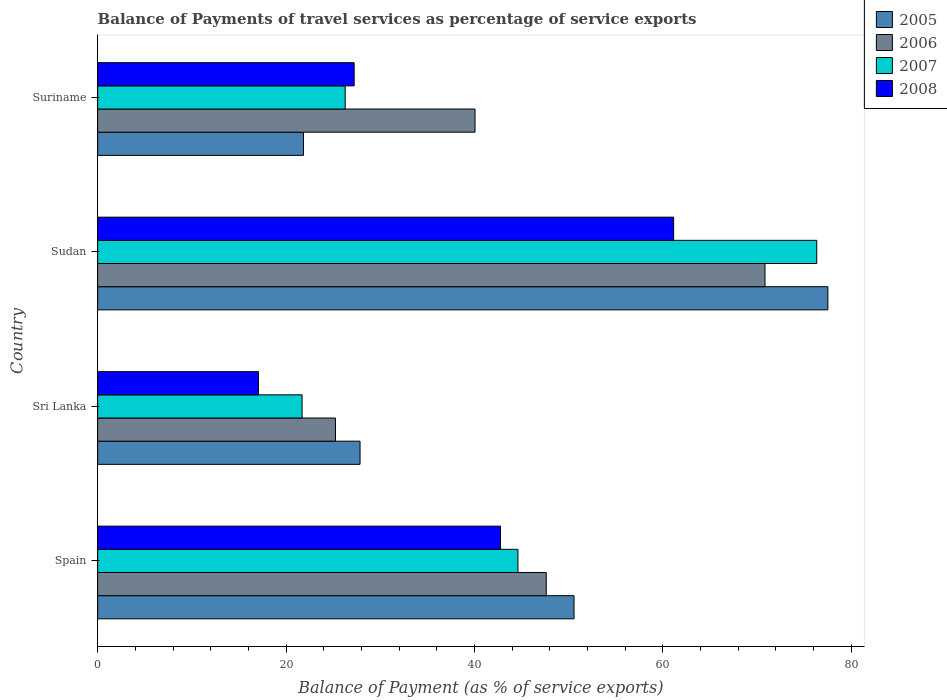How many different coloured bars are there?
Your answer should be very brief. 4. Are the number of bars per tick equal to the number of legend labels?
Provide a succinct answer. Yes. Are the number of bars on each tick of the Y-axis equal?
Your response must be concise. Yes. What is the label of the 2nd group of bars from the top?
Your response must be concise. Sudan. In how many cases, is the number of bars for a given country not equal to the number of legend labels?
Give a very brief answer. 0. What is the balance of payments of travel services in 2008 in Suriname?
Provide a short and direct response. 27.23. Across all countries, what is the maximum balance of payments of travel services in 2006?
Make the answer very short. 70.85. Across all countries, what is the minimum balance of payments of travel services in 2008?
Offer a terse response. 17.08. In which country was the balance of payments of travel services in 2005 maximum?
Provide a succinct answer. Sudan. In which country was the balance of payments of travel services in 2005 minimum?
Offer a terse response. Suriname. What is the total balance of payments of travel services in 2005 in the graph?
Offer a very short reply. 177.82. What is the difference between the balance of payments of travel services in 2005 in Spain and that in Suriname?
Your answer should be compact. 28.73. What is the difference between the balance of payments of travel services in 2007 in Sudan and the balance of payments of travel services in 2005 in Sri Lanka?
Provide a short and direct response. 48.49. What is the average balance of payments of travel services in 2005 per country?
Make the answer very short. 44.45. What is the difference between the balance of payments of travel services in 2008 and balance of payments of travel services in 2005 in Sri Lanka?
Ensure brevity in your answer.  -10.78. In how many countries, is the balance of payments of travel services in 2007 greater than 48 %?
Give a very brief answer. 1. What is the ratio of the balance of payments of travel services in 2008 in Sri Lanka to that in Sudan?
Offer a terse response. 0.28. Is the balance of payments of travel services in 2006 in Sudan less than that in Suriname?
Your answer should be very brief. No. Is the difference between the balance of payments of travel services in 2008 in Spain and Suriname greater than the difference between the balance of payments of travel services in 2005 in Spain and Suriname?
Offer a very short reply. No. What is the difference between the highest and the second highest balance of payments of travel services in 2007?
Your response must be concise. 31.73. What is the difference between the highest and the lowest balance of payments of travel services in 2006?
Your answer should be very brief. 45.6. In how many countries, is the balance of payments of travel services in 2008 greater than the average balance of payments of travel services in 2008 taken over all countries?
Give a very brief answer. 2. What does the 4th bar from the top in Spain represents?
Keep it short and to the point. 2005. What is the difference between two consecutive major ticks on the X-axis?
Make the answer very short. 20. Does the graph contain grids?
Make the answer very short. No. What is the title of the graph?
Keep it short and to the point. Balance of Payments of travel services as percentage of service exports. What is the label or title of the X-axis?
Give a very brief answer. Balance of Payment (as % of service exports). What is the Balance of Payment (as % of service exports) of 2005 in Spain?
Ensure brevity in your answer.  50.58. What is the Balance of Payment (as % of service exports) in 2006 in Spain?
Ensure brevity in your answer.  47.63. What is the Balance of Payment (as % of service exports) in 2007 in Spain?
Your answer should be compact. 44.62. What is the Balance of Payment (as % of service exports) in 2008 in Spain?
Offer a terse response. 42.78. What is the Balance of Payment (as % of service exports) in 2005 in Sri Lanka?
Make the answer very short. 27.86. What is the Balance of Payment (as % of service exports) in 2006 in Sri Lanka?
Your answer should be compact. 25.25. What is the Balance of Payment (as % of service exports) of 2007 in Sri Lanka?
Provide a short and direct response. 21.71. What is the Balance of Payment (as % of service exports) in 2008 in Sri Lanka?
Provide a succinct answer. 17.08. What is the Balance of Payment (as % of service exports) in 2005 in Sudan?
Provide a succinct answer. 77.53. What is the Balance of Payment (as % of service exports) in 2006 in Sudan?
Provide a short and direct response. 70.85. What is the Balance of Payment (as % of service exports) of 2007 in Sudan?
Provide a short and direct response. 76.35. What is the Balance of Payment (as % of service exports) in 2008 in Sudan?
Your response must be concise. 61.15. What is the Balance of Payment (as % of service exports) of 2005 in Suriname?
Keep it short and to the point. 21.85. What is the Balance of Payment (as % of service exports) in 2006 in Suriname?
Your response must be concise. 40.07. What is the Balance of Payment (as % of service exports) in 2007 in Suriname?
Your answer should be very brief. 26.28. What is the Balance of Payment (as % of service exports) in 2008 in Suriname?
Offer a very short reply. 27.23. Across all countries, what is the maximum Balance of Payment (as % of service exports) of 2005?
Offer a very short reply. 77.53. Across all countries, what is the maximum Balance of Payment (as % of service exports) in 2006?
Give a very brief answer. 70.85. Across all countries, what is the maximum Balance of Payment (as % of service exports) of 2007?
Offer a very short reply. 76.35. Across all countries, what is the maximum Balance of Payment (as % of service exports) of 2008?
Your answer should be very brief. 61.15. Across all countries, what is the minimum Balance of Payment (as % of service exports) in 2005?
Your answer should be compact. 21.85. Across all countries, what is the minimum Balance of Payment (as % of service exports) in 2006?
Provide a succinct answer. 25.25. Across all countries, what is the minimum Balance of Payment (as % of service exports) in 2007?
Provide a short and direct response. 21.71. Across all countries, what is the minimum Balance of Payment (as % of service exports) in 2008?
Your answer should be very brief. 17.08. What is the total Balance of Payment (as % of service exports) in 2005 in the graph?
Offer a terse response. 177.82. What is the total Balance of Payment (as % of service exports) of 2006 in the graph?
Offer a very short reply. 183.8. What is the total Balance of Payment (as % of service exports) of 2007 in the graph?
Offer a terse response. 168.96. What is the total Balance of Payment (as % of service exports) in 2008 in the graph?
Keep it short and to the point. 148.24. What is the difference between the Balance of Payment (as % of service exports) in 2005 in Spain and that in Sri Lanka?
Your answer should be compact. 22.72. What is the difference between the Balance of Payment (as % of service exports) in 2006 in Spain and that in Sri Lanka?
Give a very brief answer. 22.38. What is the difference between the Balance of Payment (as % of service exports) of 2007 in Spain and that in Sri Lanka?
Offer a terse response. 22.92. What is the difference between the Balance of Payment (as % of service exports) of 2008 in Spain and that in Sri Lanka?
Your response must be concise. 25.7. What is the difference between the Balance of Payment (as % of service exports) of 2005 in Spain and that in Sudan?
Your response must be concise. -26.95. What is the difference between the Balance of Payment (as % of service exports) in 2006 in Spain and that in Sudan?
Provide a succinct answer. -23.22. What is the difference between the Balance of Payment (as % of service exports) of 2007 in Spain and that in Sudan?
Your answer should be very brief. -31.73. What is the difference between the Balance of Payment (as % of service exports) in 2008 in Spain and that in Sudan?
Give a very brief answer. -18.38. What is the difference between the Balance of Payment (as % of service exports) in 2005 in Spain and that in Suriname?
Provide a succinct answer. 28.73. What is the difference between the Balance of Payment (as % of service exports) in 2006 in Spain and that in Suriname?
Provide a succinct answer. 7.56. What is the difference between the Balance of Payment (as % of service exports) in 2007 in Spain and that in Suriname?
Provide a short and direct response. 18.34. What is the difference between the Balance of Payment (as % of service exports) of 2008 in Spain and that in Suriname?
Give a very brief answer. 15.54. What is the difference between the Balance of Payment (as % of service exports) in 2005 in Sri Lanka and that in Sudan?
Make the answer very short. -49.67. What is the difference between the Balance of Payment (as % of service exports) in 2006 in Sri Lanka and that in Sudan?
Your answer should be very brief. -45.6. What is the difference between the Balance of Payment (as % of service exports) of 2007 in Sri Lanka and that in Sudan?
Keep it short and to the point. -54.64. What is the difference between the Balance of Payment (as % of service exports) of 2008 in Sri Lanka and that in Sudan?
Keep it short and to the point. -44.07. What is the difference between the Balance of Payment (as % of service exports) of 2005 in Sri Lanka and that in Suriname?
Give a very brief answer. 6.01. What is the difference between the Balance of Payment (as % of service exports) in 2006 in Sri Lanka and that in Suriname?
Keep it short and to the point. -14.82. What is the difference between the Balance of Payment (as % of service exports) of 2007 in Sri Lanka and that in Suriname?
Keep it short and to the point. -4.58. What is the difference between the Balance of Payment (as % of service exports) of 2008 in Sri Lanka and that in Suriname?
Your answer should be compact. -10.15. What is the difference between the Balance of Payment (as % of service exports) in 2005 in Sudan and that in Suriname?
Ensure brevity in your answer.  55.68. What is the difference between the Balance of Payment (as % of service exports) in 2006 in Sudan and that in Suriname?
Ensure brevity in your answer.  30.79. What is the difference between the Balance of Payment (as % of service exports) of 2007 in Sudan and that in Suriname?
Make the answer very short. 50.07. What is the difference between the Balance of Payment (as % of service exports) of 2008 in Sudan and that in Suriname?
Ensure brevity in your answer.  33.92. What is the difference between the Balance of Payment (as % of service exports) in 2005 in Spain and the Balance of Payment (as % of service exports) in 2006 in Sri Lanka?
Provide a succinct answer. 25.33. What is the difference between the Balance of Payment (as % of service exports) in 2005 in Spain and the Balance of Payment (as % of service exports) in 2007 in Sri Lanka?
Your response must be concise. 28.87. What is the difference between the Balance of Payment (as % of service exports) in 2005 in Spain and the Balance of Payment (as % of service exports) in 2008 in Sri Lanka?
Give a very brief answer. 33.5. What is the difference between the Balance of Payment (as % of service exports) of 2006 in Spain and the Balance of Payment (as % of service exports) of 2007 in Sri Lanka?
Provide a succinct answer. 25.92. What is the difference between the Balance of Payment (as % of service exports) of 2006 in Spain and the Balance of Payment (as % of service exports) of 2008 in Sri Lanka?
Provide a short and direct response. 30.55. What is the difference between the Balance of Payment (as % of service exports) in 2007 in Spain and the Balance of Payment (as % of service exports) in 2008 in Sri Lanka?
Provide a short and direct response. 27.54. What is the difference between the Balance of Payment (as % of service exports) of 2005 in Spain and the Balance of Payment (as % of service exports) of 2006 in Sudan?
Offer a terse response. -20.28. What is the difference between the Balance of Payment (as % of service exports) of 2005 in Spain and the Balance of Payment (as % of service exports) of 2007 in Sudan?
Offer a very short reply. -25.77. What is the difference between the Balance of Payment (as % of service exports) in 2005 in Spain and the Balance of Payment (as % of service exports) in 2008 in Sudan?
Provide a succinct answer. -10.57. What is the difference between the Balance of Payment (as % of service exports) of 2006 in Spain and the Balance of Payment (as % of service exports) of 2007 in Sudan?
Your answer should be very brief. -28.72. What is the difference between the Balance of Payment (as % of service exports) of 2006 in Spain and the Balance of Payment (as % of service exports) of 2008 in Sudan?
Make the answer very short. -13.52. What is the difference between the Balance of Payment (as % of service exports) in 2007 in Spain and the Balance of Payment (as % of service exports) in 2008 in Sudan?
Your answer should be very brief. -16.53. What is the difference between the Balance of Payment (as % of service exports) of 2005 in Spain and the Balance of Payment (as % of service exports) of 2006 in Suriname?
Ensure brevity in your answer.  10.51. What is the difference between the Balance of Payment (as % of service exports) of 2005 in Spain and the Balance of Payment (as % of service exports) of 2007 in Suriname?
Give a very brief answer. 24.3. What is the difference between the Balance of Payment (as % of service exports) of 2005 in Spain and the Balance of Payment (as % of service exports) of 2008 in Suriname?
Provide a short and direct response. 23.34. What is the difference between the Balance of Payment (as % of service exports) in 2006 in Spain and the Balance of Payment (as % of service exports) in 2007 in Suriname?
Offer a very short reply. 21.35. What is the difference between the Balance of Payment (as % of service exports) of 2006 in Spain and the Balance of Payment (as % of service exports) of 2008 in Suriname?
Provide a succinct answer. 20.4. What is the difference between the Balance of Payment (as % of service exports) in 2007 in Spain and the Balance of Payment (as % of service exports) in 2008 in Suriname?
Your response must be concise. 17.39. What is the difference between the Balance of Payment (as % of service exports) of 2005 in Sri Lanka and the Balance of Payment (as % of service exports) of 2006 in Sudan?
Offer a terse response. -43. What is the difference between the Balance of Payment (as % of service exports) of 2005 in Sri Lanka and the Balance of Payment (as % of service exports) of 2007 in Sudan?
Ensure brevity in your answer.  -48.49. What is the difference between the Balance of Payment (as % of service exports) in 2005 in Sri Lanka and the Balance of Payment (as % of service exports) in 2008 in Sudan?
Keep it short and to the point. -33.29. What is the difference between the Balance of Payment (as % of service exports) in 2006 in Sri Lanka and the Balance of Payment (as % of service exports) in 2007 in Sudan?
Your response must be concise. -51.1. What is the difference between the Balance of Payment (as % of service exports) in 2006 in Sri Lanka and the Balance of Payment (as % of service exports) in 2008 in Sudan?
Make the answer very short. -35.9. What is the difference between the Balance of Payment (as % of service exports) of 2007 in Sri Lanka and the Balance of Payment (as % of service exports) of 2008 in Sudan?
Provide a succinct answer. -39.45. What is the difference between the Balance of Payment (as % of service exports) of 2005 in Sri Lanka and the Balance of Payment (as % of service exports) of 2006 in Suriname?
Offer a very short reply. -12.21. What is the difference between the Balance of Payment (as % of service exports) in 2005 in Sri Lanka and the Balance of Payment (as % of service exports) in 2007 in Suriname?
Keep it short and to the point. 1.58. What is the difference between the Balance of Payment (as % of service exports) in 2005 in Sri Lanka and the Balance of Payment (as % of service exports) in 2008 in Suriname?
Ensure brevity in your answer.  0.62. What is the difference between the Balance of Payment (as % of service exports) of 2006 in Sri Lanka and the Balance of Payment (as % of service exports) of 2007 in Suriname?
Make the answer very short. -1.03. What is the difference between the Balance of Payment (as % of service exports) of 2006 in Sri Lanka and the Balance of Payment (as % of service exports) of 2008 in Suriname?
Ensure brevity in your answer.  -1.98. What is the difference between the Balance of Payment (as % of service exports) in 2007 in Sri Lanka and the Balance of Payment (as % of service exports) in 2008 in Suriname?
Provide a succinct answer. -5.53. What is the difference between the Balance of Payment (as % of service exports) in 2005 in Sudan and the Balance of Payment (as % of service exports) in 2006 in Suriname?
Provide a short and direct response. 37.46. What is the difference between the Balance of Payment (as % of service exports) in 2005 in Sudan and the Balance of Payment (as % of service exports) in 2007 in Suriname?
Your response must be concise. 51.25. What is the difference between the Balance of Payment (as % of service exports) of 2005 in Sudan and the Balance of Payment (as % of service exports) of 2008 in Suriname?
Your answer should be compact. 50.29. What is the difference between the Balance of Payment (as % of service exports) of 2006 in Sudan and the Balance of Payment (as % of service exports) of 2007 in Suriname?
Provide a short and direct response. 44.57. What is the difference between the Balance of Payment (as % of service exports) of 2006 in Sudan and the Balance of Payment (as % of service exports) of 2008 in Suriname?
Give a very brief answer. 43.62. What is the difference between the Balance of Payment (as % of service exports) of 2007 in Sudan and the Balance of Payment (as % of service exports) of 2008 in Suriname?
Provide a succinct answer. 49.12. What is the average Balance of Payment (as % of service exports) of 2005 per country?
Your response must be concise. 44.45. What is the average Balance of Payment (as % of service exports) in 2006 per country?
Your answer should be very brief. 45.95. What is the average Balance of Payment (as % of service exports) of 2007 per country?
Provide a succinct answer. 42.24. What is the average Balance of Payment (as % of service exports) in 2008 per country?
Your answer should be compact. 37.06. What is the difference between the Balance of Payment (as % of service exports) of 2005 and Balance of Payment (as % of service exports) of 2006 in Spain?
Offer a very short reply. 2.95. What is the difference between the Balance of Payment (as % of service exports) in 2005 and Balance of Payment (as % of service exports) in 2007 in Spain?
Your response must be concise. 5.96. What is the difference between the Balance of Payment (as % of service exports) of 2005 and Balance of Payment (as % of service exports) of 2008 in Spain?
Make the answer very short. 7.8. What is the difference between the Balance of Payment (as % of service exports) of 2006 and Balance of Payment (as % of service exports) of 2007 in Spain?
Offer a terse response. 3.01. What is the difference between the Balance of Payment (as % of service exports) in 2006 and Balance of Payment (as % of service exports) in 2008 in Spain?
Keep it short and to the point. 4.86. What is the difference between the Balance of Payment (as % of service exports) in 2007 and Balance of Payment (as % of service exports) in 2008 in Spain?
Keep it short and to the point. 1.85. What is the difference between the Balance of Payment (as % of service exports) in 2005 and Balance of Payment (as % of service exports) in 2006 in Sri Lanka?
Provide a short and direct response. 2.61. What is the difference between the Balance of Payment (as % of service exports) in 2005 and Balance of Payment (as % of service exports) in 2007 in Sri Lanka?
Provide a short and direct response. 6.15. What is the difference between the Balance of Payment (as % of service exports) in 2005 and Balance of Payment (as % of service exports) in 2008 in Sri Lanka?
Your answer should be compact. 10.78. What is the difference between the Balance of Payment (as % of service exports) in 2006 and Balance of Payment (as % of service exports) in 2007 in Sri Lanka?
Keep it short and to the point. 3.54. What is the difference between the Balance of Payment (as % of service exports) of 2006 and Balance of Payment (as % of service exports) of 2008 in Sri Lanka?
Offer a terse response. 8.17. What is the difference between the Balance of Payment (as % of service exports) in 2007 and Balance of Payment (as % of service exports) in 2008 in Sri Lanka?
Offer a terse response. 4.63. What is the difference between the Balance of Payment (as % of service exports) of 2005 and Balance of Payment (as % of service exports) of 2006 in Sudan?
Make the answer very short. 6.67. What is the difference between the Balance of Payment (as % of service exports) in 2005 and Balance of Payment (as % of service exports) in 2007 in Sudan?
Provide a succinct answer. 1.18. What is the difference between the Balance of Payment (as % of service exports) of 2005 and Balance of Payment (as % of service exports) of 2008 in Sudan?
Offer a very short reply. 16.38. What is the difference between the Balance of Payment (as % of service exports) of 2006 and Balance of Payment (as % of service exports) of 2007 in Sudan?
Offer a terse response. -5.5. What is the difference between the Balance of Payment (as % of service exports) of 2006 and Balance of Payment (as % of service exports) of 2008 in Sudan?
Provide a short and direct response. 9.7. What is the difference between the Balance of Payment (as % of service exports) of 2007 and Balance of Payment (as % of service exports) of 2008 in Sudan?
Give a very brief answer. 15.2. What is the difference between the Balance of Payment (as % of service exports) in 2005 and Balance of Payment (as % of service exports) in 2006 in Suriname?
Offer a terse response. -18.22. What is the difference between the Balance of Payment (as % of service exports) of 2005 and Balance of Payment (as % of service exports) of 2007 in Suriname?
Offer a terse response. -4.43. What is the difference between the Balance of Payment (as % of service exports) of 2005 and Balance of Payment (as % of service exports) of 2008 in Suriname?
Ensure brevity in your answer.  -5.38. What is the difference between the Balance of Payment (as % of service exports) of 2006 and Balance of Payment (as % of service exports) of 2007 in Suriname?
Make the answer very short. 13.79. What is the difference between the Balance of Payment (as % of service exports) in 2006 and Balance of Payment (as % of service exports) in 2008 in Suriname?
Offer a terse response. 12.83. What is the difference between the Balance of Payment (as % of service exports) of 2007 and Balance of Payment (as % of service exports) of 2008 in Suriname?
Your response must be concise. -0.95. What is the ratio of the Balance of Payment (as % of service exports) in 2005 in Spain to that in Sri Lanka?
Provide a short and direct response. 1.82. What is the ratio of the Balance of Payment (as % of service exports) of 2006 in Spain to that in Sri Lanka?
Make the answer very short. 1.89. What is the ratio of the Balance of Payment (as % of service exports) of 2007 in Spain to that in Sri Lanka?
Make the answer very short. 2.06. What is the ratio of the Balance of Payment (as % of service exports) in 2008 in Spain to that in Sri Lanka?
Keep it short and to the point. 2.5. What is the ratio of the Balance of Payment (as % of service exports) in 2005 in Spain to that in Sudan?
Give a very brief answer. 0.65. What is the ratio of the Balance of Payment (as % of service exports) of 2006 in Spain to that in Sudan?
Keep it short and to the point. 0.67. What is the ratio of the Balance of Payment (as % of service exports) in 2007 in Spain to that in Sudan?
Your response must be concise. 0.58. What is the ratio of the Balance of Payment (as % of service exports) of 2008 in Spain to that in Sudan?
Your answer should be compact. 0.7. What is the ratio of the Balance of Payment (as % of service exports) in 2005 in Spain to that in Suriname?
Ensure brevity in your answer.  2.31. What is the ratio of the Balance of Payment (as % of service exports) in 2006 in Spain to that in Suriname?
Your response must be concise. 1.19. What is the ratio of the Balance of Payment (as % of service exports) of 2007 in Spain to that in Suriname?
Offer a terse response. 1.7. What is the ratio of the Balance of Payment (as % of service exports) in 2008 in Spain to that in Suriname?
Offer a terse response. 1.57. What is the ratio of the Balance of Payment (as % of service exports) of 2005 in Sri Lanka to that in Sudan?
Ensure brevity in your answer.  0.36. What is the ratio of the Balance of Payment (as % of service exports) in 2006 in Sri Lanka to that in Sudan?
Your answer should be very brief. 0.36. What is the ratio of the Balance of Payment (as % of service exports) of 2007 in Sri Lanka to that in Sudan?
Your answer should be very brief. 0.28. What is the ratio of the Balance of Payment (as % of service exports) in 2008 in Sri Lanka to that in Sudan?
Provide a short and direct response. 0.28. What is the ratio of the Balance of Payment (as % of service exports) in 2005 in Sri Lanka to that in Suriname?
Provide a succinct answer. 1.27. What is the ratio of the Balance of Payment (as % of service exports) in 2006 in Sri Lanka to that in Suriname?
Your answer should be very brief. 0.63. What is the ratio of the Balance of Payment (as % of service exports) in 2007 in Sri Lanka to that in Suriname?
Make the answer very short. 0.83. What is the ratio of the Balance of Payment (as % of service exports) in 2008 in Sri Lanka to that in Suriname?
Your response must be concise. 0.63. What is the ratio of the Balance of Payment (as % of service exports) in 2005 in Sudan to that in Suriname?
Your response must be concise. 3.55. What is the ratio of the Balance of Payment (as % of service exports) in 2006 in Sudan to that in Suriname?
Provide a succinct answer. 1.77. What is the ratio of the Balance of Payment (as % of service exports) of 2007 in Sudan to that in Suriname?
Make the answer very short. 2.9. What is the ratio of the Balance of Payment (as % of service exports) in 2008 in Sudan to that in Suriname?
Offer a terse response. 2.25. What is the difference between the highest and the second highest Balance of Payment (as % of service exports) in 2005?
Your answer should be compact. 26.95. What is the difference between the highest and the second highest Balance of Payment (as % of service exports) in 2006?
Ensure brevity in your answer.  23.22. What is the difference between the highest and the second highest Balance of Payment (as % of service exports) in 2007?
Ensure brevity in your answer.  31.73. What is the difference between the highest and the second highest Balance of Payment (as % of service exports) of 2008?
Offer a terse response. 18.38. What is the difference between the highest and the lowest Balance of Payment (as % of service exports) of 2005?
Your answer should be very brief. 55.68. What is the difference between the highest and the lowest Balance of Payment (as % of service exports) of 2006?
Your response must be concise. 45.6. What is the difference between the highest and the lowest Balance of Payment (as % of service exports) in 2007?
Make the answer very short. 54.64. What is the difference between the highest and the lowest Balance of Payment (as % of service exports) of 2008?
Keep it short and to the point. 44.07. 